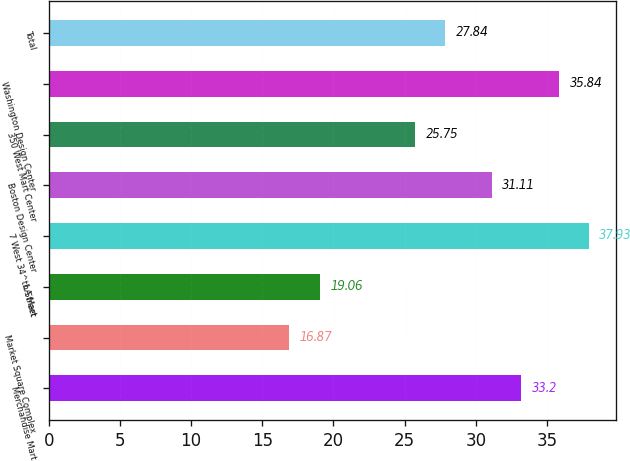<chart> <loc_0><loc_0><loc_500><loc_500><bar_chart><fcel>Merchandise Mart<fcel>Market Square Complex<fcel>LA Mart<fcel>7 West 34^th Street<fcel>Boston Design Center<fcel>350 West Mart Center<fcel>Washington Design Center<fcel>Total<nl><fcel>33.2<fcel>16.87<fcel>19.06<fcel>37.93<fcel>31.11<fcel>25.75<fcel>35.84<fcel>27.84<nl></chart> 